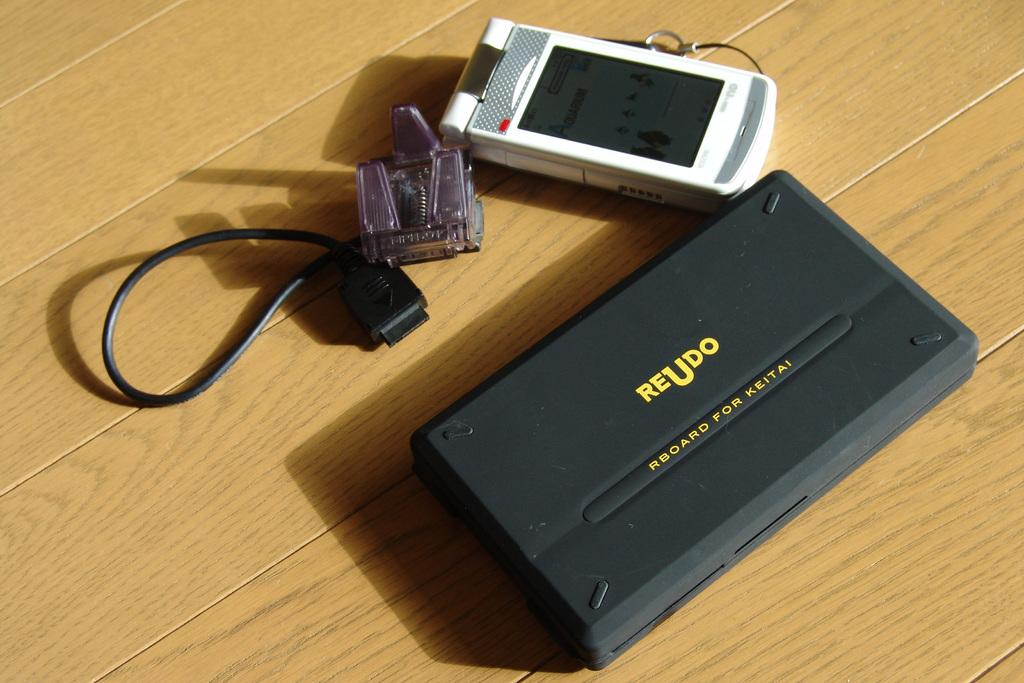<image>
Summarize the visual content of the image. An rboard made by Reudo sits on a wooden table. 